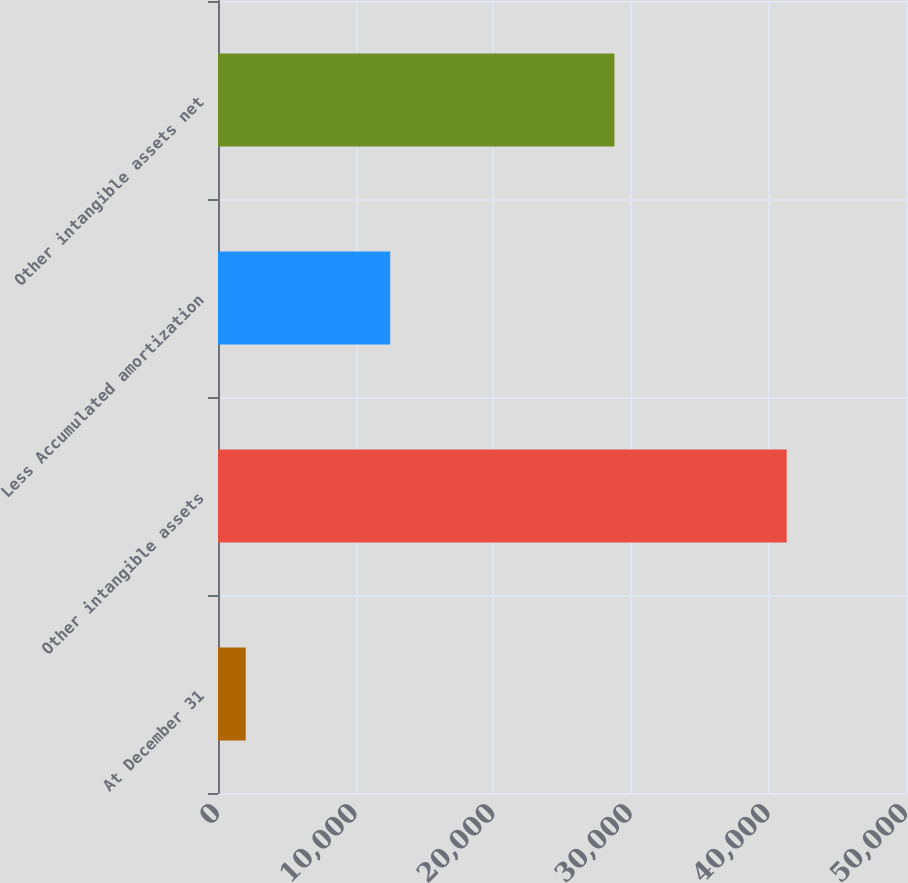Convert chart to OTSL. <chart><loc_0><loc_0><loc_500><loc_500><bar_chart><fcel>At December 31<fcel>Other intangible assets<fcel>Less Accumulated amortization<fcel>Other intangible assets net<nl><fcel>2014<fcel>41327<fcel>12512<fcel>28815<nl></chart> 